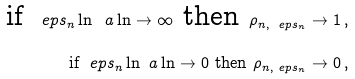<formula> <loc_0><loc_0><loc_500><loc_500>\text {if } \ e p s _ { n } \ln ^ { \ } a \ln \to \infty \text { then } \rho _ { n , \ e p s _ { n } } \to 1 \, , \\ \text {if } \ e p s _ { n } \ln ^ { \ } a \ln \to 0 \text { then } \rho _ { n , \ e p s _ { n } } \to 0 \, ,</formula> 